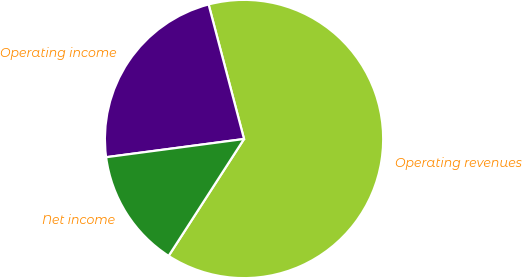Convert chart to OTSL. <chart><loc_0><loc_0><loc_500><loc_500><pie_chart><fcel>Operating revenues<fcel>Operating income<fcel>Net income<nl><fcel>63.21%<fcel>22.99%<fcel>13.79%<nl></chart> 